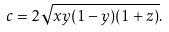<formula> <loc_0><loc_0><loc_500><loc_500>c = 2 \sqrt { x y ( 1 - y ) ( 1 + z ) } .</formula> 